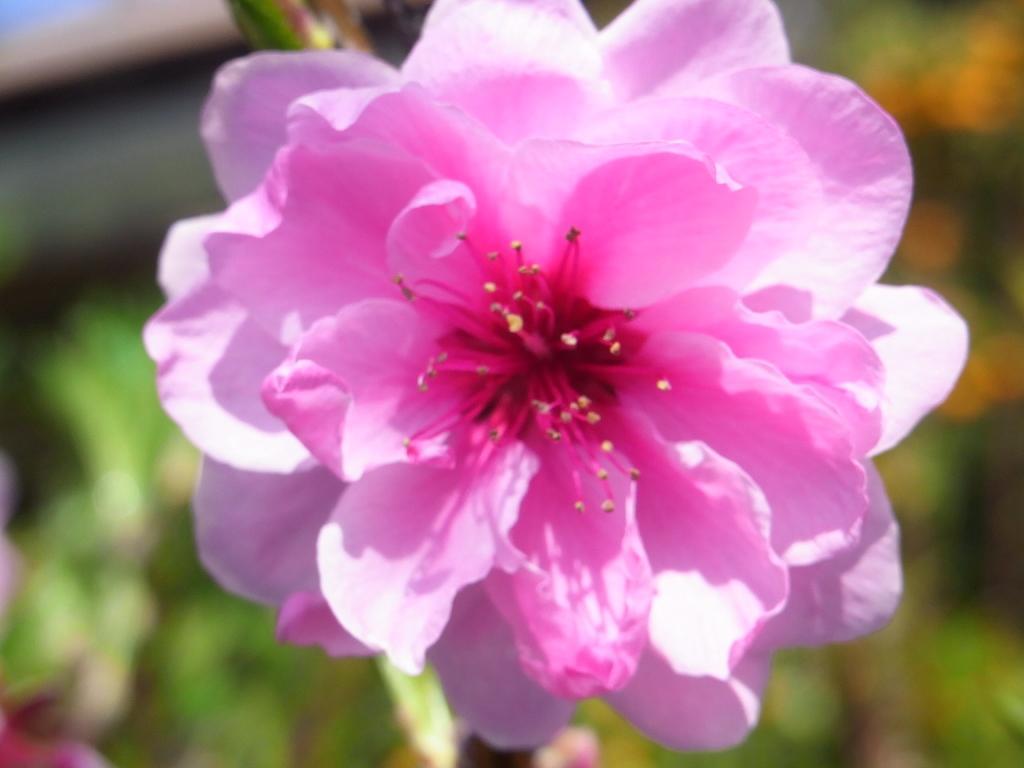Can you describe this image briefly? There is a pink color flower of a plant. And the background is blurred. 